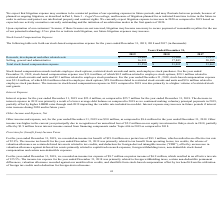According to Xperi Corporation's financial document, What is included in stock-based compensation awards? employee stock options, restricted stock awards and units, and employee stock purchases. The document states: "Stock-based compensation awards include employee stock options, restricted stock awards and units, and employee stock purchases. For the year ended De..." Also, What were the stock-based compensation expenses for the year ended December 31, 2018, and 2019, respectively? The document shows two values: $31.0 million and $31.6 million. From the document: "ber 31, 2018, stock-based compensation expense was $31.0 million, of which $0.4 million related to employee stock options, $28.0 million related to re..." Also, What caused the increment in stock-based compensation expense in 2019 compared to 2018? a higher volume of restricted stock unit grants. The document states: "nse in 2019 compared to 2018 was due primarily to a higher volume of restricted stock unit grants...." Also, can you calculate: What is the overall proportion of employee stock options and employee stock purchases over total stock-based compensation expense in 2019? To answer this question, I need to perform calculations using the financial data. The calculation is: (0.2+2.3)/31.6 , which equals 0.08. This is based on the information: "r 31, 2019, stock-based compensation expense was $31.6 million, of which $0.2 million related to employee stock options, $29.1 million related to restrict compensation expense was $31.6 million, of wh..." The key data points involved are: 0.2, 2.3, 31.6. Also, can you calculate: What is the percentage change in total stock-based compensation expense in 2018 compared to 2017? To answer this question, I need to perform calculations using the financial data. The calculation is: (31,011-33,462)/33,462 , which equals -7.32 (percentage). This is based on the information: "Total stock-based compensation expense $ 31,554 $ 31,011 $ 33,462 ck-based compensation expense $ 31,554 $ 31,011 $ 33,462..." The key data points involved are: 31,011, 33,462. Also, can you calculate: What is the total stock-based compensation expense related to research, development, and other related costs from 2017 to 2019? Based on the calculation: 14,643+13,168+13,277 , the result is 41088 (in thousands). This is based on the information: "pment and other related costs $ 14,643 $ 13,168 $ 13,277 h, development and other related costs $ 14,643 $ 13,168 $ 13,277 Research, development and other related costs $ 14,643 $ 13,168 $ 13,277..." The key data points involved are: 13,168, 13,277, 14,643. 